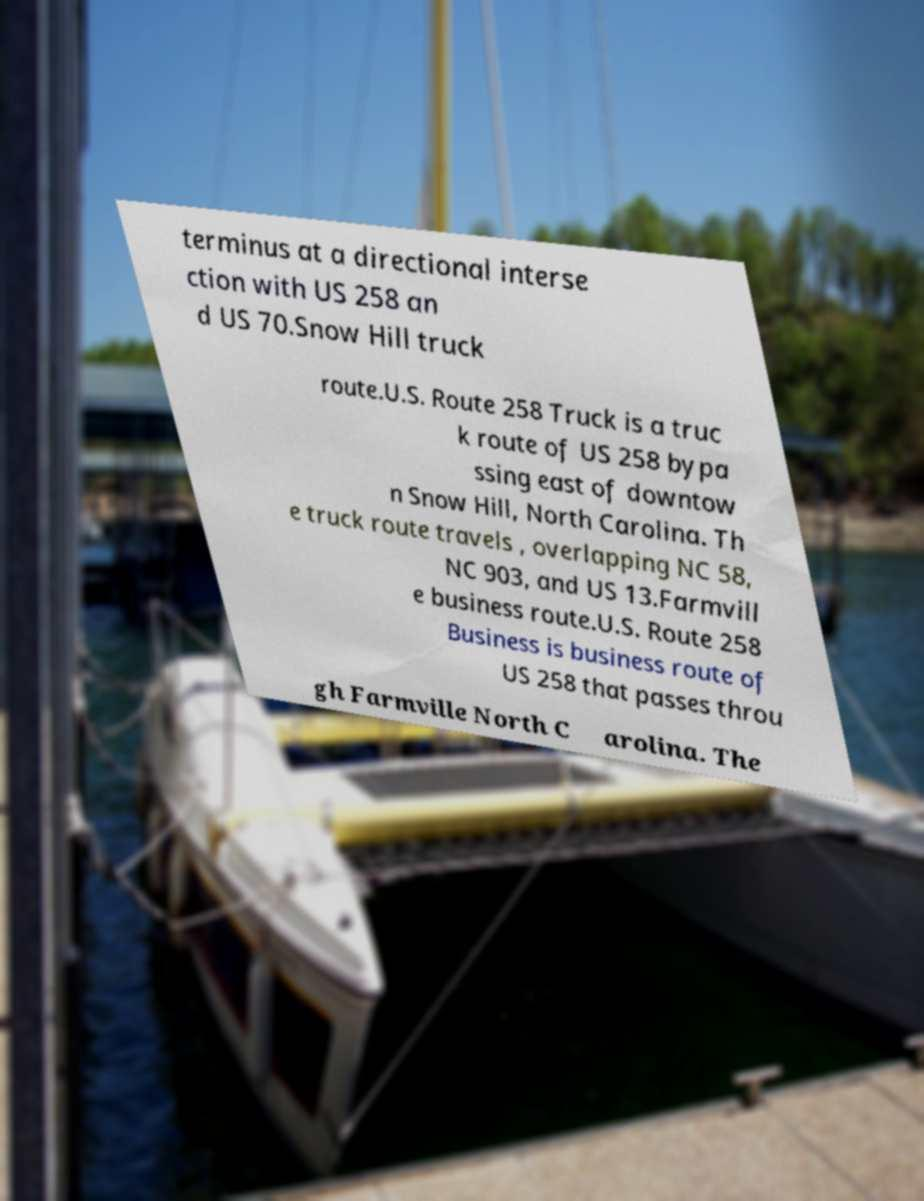What messages or text are displayed in this image? I need them in a readable, typed format. terminus at a directional interse ction with US 258 an d US 70.Snow Hill truck route.U.S. Route 258 Truck is a truc k route of US 258 bypa ssing east of downtow n Snow Hill, North Carolina. Th e truck route travels , overlapping NC 58, NC 903, and US 13.Farmvill e business route.U.S. Route 258 Business is business route of US 258 that passes throu gh Farmville North C arolina. The 